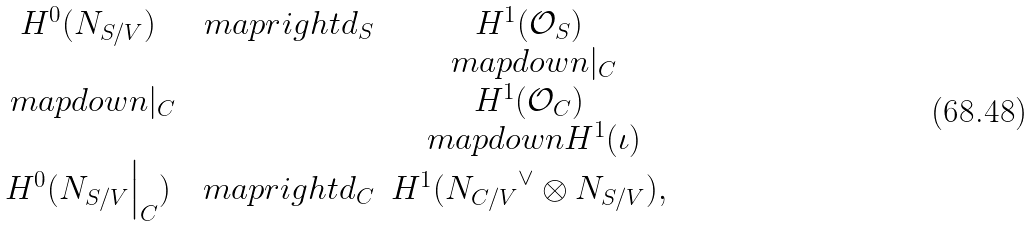Convert formula to latex. <formula><loc_0><loc_0><loc_500><loc_500>\begin{array} { c c c c c } H ^ { 0 } ( N _ { S / V } ) & \ m a p r i g h t { d _ { S } } & H ^ { 1 } ( \mathcal { O } _ { S } ) \\ & & \ m a p d o w n { | _ { C } } \\ \ m a p d o w n { | _ { C } } & & H ^ { 1 } ( \mathcal { O } _ { C } ) \\ & & \ m a p d o w n { H ^ { 1 } ( \iota ) } \\ H ^ { 0 } ( N _ { S / V } \Big { | } _ { C } ) & \ m a p r i g h t { d _ { C } } & H ^ { 1 } ( { N _ { C / V } } ^ { \vee } \otimes N _ { S / V } ) , \end{array}</formula> 